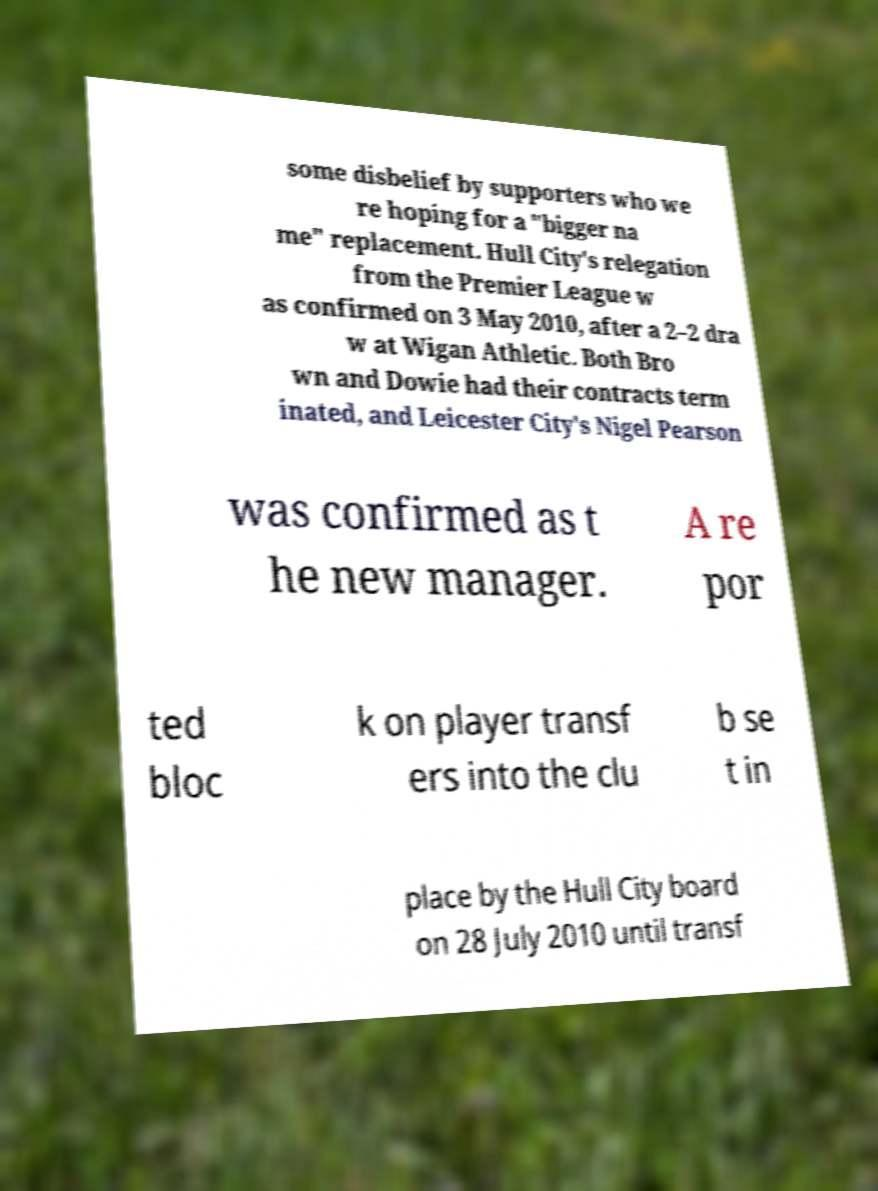Can you accurately transcribe the text from the provided image for me? some disbelief by supporters who we re hoping for a "bigger na me" replacement. Hull City's relegation from the Premier League w as confirmed on 3 May 2010, after a 2–2 dra w at Wigan Athletic. Both Bro wn and Dowie had their contracts term inated, and Leicester City's Nigel Pearson was confirmed as t he new manager. A re por ted bloc k on player transf ers into the clu b se t in place by the Hull City board on 28 July 2010 until transf 